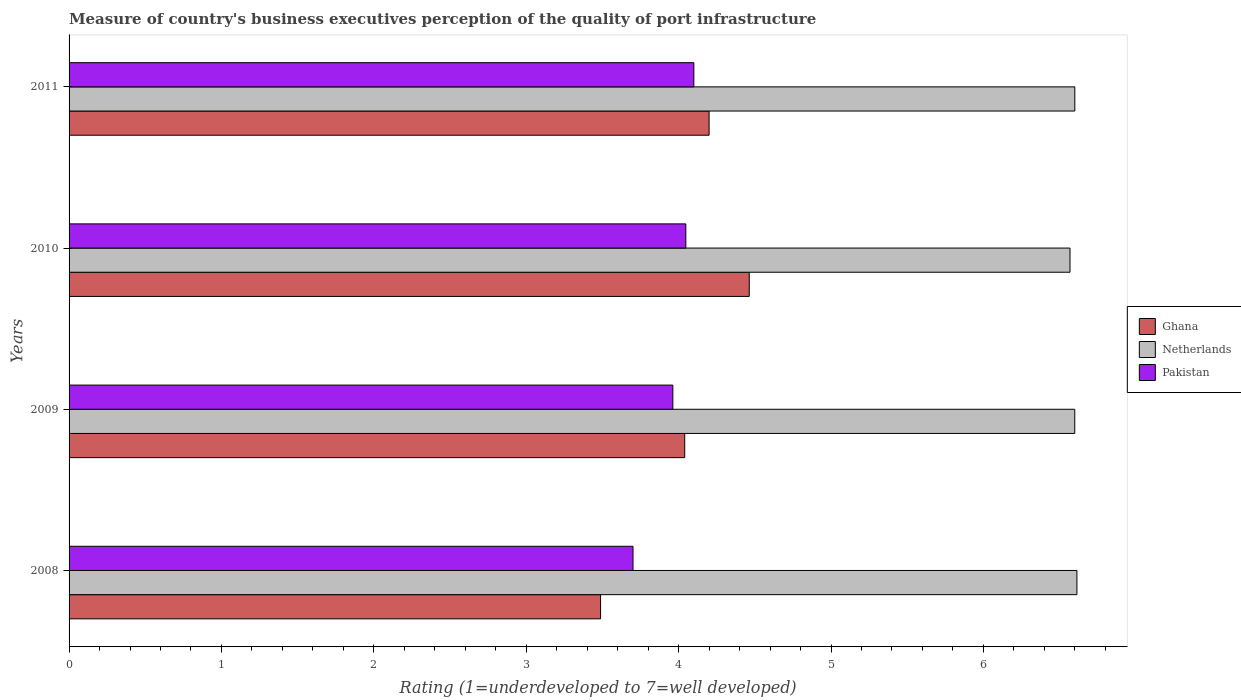How many different coloured bars are there?
Your answer should be compact. 3. How many groups of bars are there?
Offer a very short reply. 4. Are the number of bars per tick equal to the number of legend labels?
Make the answer very short. Yes. How many bars are there on the 2nd tick from the bottom?
Make the answer very short. 3. What is the ratings of the quality of port infrastructure in Ghana in 2009?
Offer a very short reply. 4.04. Across all years, what is the maximum ratings of the quality of port infrastructure in Pakistan?
Provide a short and direct response. 4.1. Across all years, what is the minimum ratings of the quality of port infrastructure in Pakistan?
Offer a terse response. 3.7. In which year was the ratings of the quality of port infrastructure in Ghana maximum?
Your answer should be compact. 2010. What is the total ratings of the quality of port infrastructure in Ghana in the graph?
Provide a succinct answer. 16.19. What is the difference between the ratings of the quality of port infrastructure in Netherlands in 2008 and that in 2011?
Your answer should be compact. 0.01. What is the difference between the ratings of the quality of port infrastructure in Ghana in 2009 and the ratings of the quality of port infrastructure in Netherlands in 2008?
Ensure brevity in your answer.  -2.57. What is the average ratings of the quality of port infrastructure in Ghana per year?
Your answer should be very brief. 4.05. In the year 2010, what is the difference between the ratings of the quality of port infrastructure in Netherlands and ratings of the quality of port infrastructure in Pakistan?
Keep it short and to the point. 2.52. In how many years, is the ratings of the quality of port infrastructure in Pakistan greater than 6.6 ?
Provide a short and direct response. 0. What is the ratio of the ratings of the quality of port infrastructure in Netherlands in 2010 to that in 2011?
Offer a terse response. 1. Is the ratings of the quality of port infrastructure in Netherlands in 2008 less than that in 2010?
Offer a terse response. No. What is the difference between the highest and the second highest ratings of the quality of port infrastructure in Netherlands?
Keep it short and to the point. 0.01. What is the difference between the highest and the lowest ratings of the quality of port infrastructure in Netherlands?
Your answer should be compact. 0.05. In how many years, is the ratings of the quality of port infrastructure in Netherlands greater than the average ratings of the quality of port infrastructure in Netherlands taken over all years?
Offer a terse response. 3. What does the 1st bar from the top in 2009 represents?
Keep it short and to the point. Pakistan. How many bars are there?
Provide a short and direct response. 12. How many years are there in the graph?
Give a very brief answer. 4. What is the difference between two consecutive major ticks on the X-axis?
Ensure brevity in your answer.  1. Are the values on the major ticks of X-axis written in scientific E-notation?
Your response must be concise. No. Does the graph contain grids?
Provide a short and direct response. No. Where does the legend appear in the graph?
Offer a terse response. Center right. How are the legend labels stacked?
Give a very brief answer. Vertical. What is the title of the graph?
Give a very brief answer. Measure of country's business executives perception of the quality of port infrastructure. What is the label or title of the X-axis?
Your response must be concise. Rating (1=underdeveloped to 7=well developed). What is the label or title of the Y-axis?
Your answer should be very brief. Years. What is the Rating (1=underdeveloped to 7=well developed) in Ghana in 2008?
Your answer should be compact. 3.49. What is the Rating (1=underdeveloped to 7=well developed) of Netherlands in 2008?
Your answer should be compact. 6.61. What is the Rating (1=underdeveloped to 7=well developed) in Pakistan in 2008?
Make the answer very short. 3.7. What is the Rating (1=underdeveloped to 7=well developed) of Ghana in 2009?
Ensure brevity in your answer.  4.04. What is the Rating (1=underdeveloped to 7=well developed) of Netherlands in 2009?
Ensure brevity in your answer.  6.6. What is the Rating (1=underdeveloped to 7=well developed) in Pakistan in 2009?
Provide a succinct answer. 3.96. What is the Rating (1=underdeveloped to 7=well developed) in Ghana in 2010?
Make the answer very short. 4.46. What is the Rating (1=underdeveloped to 7=well developed) in Netherlands in 2010?
Provide a succinct answer. 6.57. What is the Rating (1=underdeveloped to 7=well developed) of Pakistan in 2010?
Make the answer very short. 4.05. What is the Rating (1=underdeveloped to 7=well developed) of Netherlands in 2011?
Offer a very short reply. 6.6. Across all years, what is the maximum Rating (1=underdeveloped to 7=well developed) in Ghana?
Offer a terse response. 4.46. Across all years, what is the maximum Rating (1=underdeveloped to 7=well developed) of Netherlands?
Give a very brief answer. 6.61. Across all years, what is the maximum Rating (1=underdeveloped to 7=well developed) of Pakistan?
Offer a very short reply. 4.1. Across all years, what is the minimum Rating (1=underdeveloped to 7=well developed) in Ghana?
Your answer should be compact. 3.49. Across all years, what is the minimum Rating (1=underdeveloped to 7=well developed) of Netherlands?
Your response must be concise. 6.57. Across all years, what is the minimum Rating (1=underdeveloped to 7=well developed) of Pakistan?
Make the answer very short. 3.7. What is the total Rating (1=underdeveloped to 7=well developed) of Ghana in the graph?
Your answer should be very brief. 16.19. What is the total Rating (1=underdeveloped to 7=well developed) in Netherlands in the graph?
Give a very brief answer. 26.38. What is the total Rating (1=underdeveloped to 7=well developed) in Pakistan in the graph?
Provide a succinct answer. 15.81. What is the difference between the Rating (1=underdeveloped to 7=well developed) of Ghana in 2008 and that in 2009?
Keep it short and to the point. -0.55. What is the difference between the Rating (1=underdeveloped to 7=well developed) in Netherlands in 2008 and that in 2009?
Ensure brevity in your answer.  0.01. What is the difference between the Rating (1=underdeveloped to 7=well developed) of Pakistan in 2008 and that in 2009?
Offer a terse response. -0.26. What is the difference between the Rating (1=underdeveloped to 7=well developed) in Ghana in 2008 and that in 2010?
Offer a very short reply. -0.98. What is the difference between the Rating (1=underdeveloped to 7=well developed) of Netherlands in 2008 and that in 2010?
Make the answer very short. 0.05. What is the difference between the Rating (1=underdeveloped to 7=well developed) in Pakistan in 2008 and that in 2010?
Your response must be concise. -0.35. What is the difference between the Rating (1=underdeveloped to 7=well developed) of Ghana in 2008 and that in 2011?
Keep it short and to the point. -0.71. What is the difference between the Rating (1=underdeveloped to 7=well developed) of Netherlands in 2008 and that in 2011?
Offer a terse response. 0.01. What is the difference between the Rating (1=underdeveloped to 7=well developed) of Pakistan in 2008 and that in 2011?
Keep it short and to the point. -0.4. What is the difference between the Rating (1=underdeveloped to 7=well developed) in Ghana in 2009 and that in 2010?
Your answer should be very brief. -0.42. What is the difference between the Rating (1=underdeveloped to 7=well developed) of Netherlands in 2009 and that in 2010?
Offer a very short reply. 0.03. What is the difference between the Rating (1=underdeveloped to 7=well developed) of Pakistan in 2009 and that in 2010?
Your answer should be very brief. -0.09. What is the difference between the Rating (1=underdeveloped to 7=well developed) of Ghana in 2009 and that in 2011?
Your answer should be very brief. -0.16. What is the difference between the Rating (1=underdeveloped to 7=well developed) of Netherlands in 2009 and that in 2011?
Your answer should be compact. -0. What is the difference between the Rating (1=underdeveloped to 7=well developed) of Pakistan in 2009 and that in 2011?
Your answer should be compact. -0.14. What is the difference between the Rating (1=underdeveloped to 7=well developed) in Ghana in 2010 and that in 2011?
Your answer should be very brief. 0.26. What is the difference between the Rating (1=underdeveloped to 7=well developed) in Netherlands in 2010 and that in 2011?
Ensure brevity in your answer.  -0.03. What is the difference between the Rating (1=underdeveloped to 7=well developed) of Pakistan in 2010 and that in 2011?
Ensure brevity in your answer.  -0.05. What is the difference between the Rating (1=underdeveloped to 7=well developed) of Ghana in 2008 and the Rating (1=underdeveloped to 7=well developed) of Netherlands in 2009?
Give a very brief answer. -3.11. What is the difference between the Rating (1=underdeveloped to 7=well developed) of Ghana in 2008 and the Rating (1=underdeveloped to 7=well developed) of Pakistan in 2009?
Your answer should be very brief. -0.47. What is the difference between the Rating (1=underdeveloped to 7=well developed) of Netherlands in 2008 and the Rating (1=underdeveloped to 7=well developed) of Pakistan in 2009?
Keep it short and to the point. 2.65. What is the difference between the Rating (1=underdeveloped to 7=well developed) of Ghana in 2008 and the Rating (1=underdeveloped to 7=well developed) of Netherlands in 2010?
Keep it short and to the point. -3.08. What is the difference between the Rating (1=underdeveloped to 7=well developed) in Ghana in 2008 and the Rating (1=underdeveloped to 7=well developed) in Pakistan in 2010?
Make the answer very short. -0.56. What is the difference between the Rating (1=underdeveloped to 7=well developed) in Netherlands in 2008 and the Rating (1=underdeveloped to 7=well developed) in Pakistan in 2010?
Offer a terse response. 2.57. What is the difference between the Rating (1=underdeveloped to 7=well developed) of Ghana in 2008 and the Rating (1=underdeveloped to 7=well developed) of Netherlands in 2011?
Provide a short and direct response. -3.11. What is the difference between the Rating (1=underdeveloped to 7=well developed) in Ghana in 2008 and the Rating (1=underdeveloped to 7=well developed) in Pakistan in 2011?
Make the answer very short. -0.61. What is the difference between the Rating (1=underdeveloped to 7=well developed) of Netherlands in 2008 and the Rating (1=underdeveloped to 7=well developed) of Pakistan in 2011?
Ensure brevity in your answer.  2.51. What is the difference between the Rating (1=underdeveloped to 7=well developed) of Ghana in 2009 and the Rating (1=underdeveloped to 7=well developed) of Netherlands in 2010?
Your answer should be very brief. -2.53. What is the difference between the Rating (1=underdeveloped to 7=well developed) of Ghana in 2009 and the Rating (1=underdeveloped to 7=well developed) of Pakistan in 2010?
Keep it short and to the point. -0.01. What is the difference between the Rating (1=underdeveloped to 7=well developed) in Netherlands in 2009 and the Rating (1=underdeveloped to 7=well developed) in Pakistan in 2010?
Provide a short and direct response. 2.55. What is the difference between the Rating (1=underdeveloped to 7=well developed) in Ghana in 2009 and the Rating (1=underdeveloped to 7=well developed) in Netherlands in 2011?
Provide a succinct answer. -2.56. What is the difference between the Rating (1=underdeveloped to 7=well developed) in Ghana in 2009 and the Rating (1=underdeveloped to 7=well developed) in Pakistan in 2011?
Your response must be concise. -0.06. What is the difference between the Rating (1=underdeveloped to 7=well developed) in Netherlands in 2009 and the Rating (1=underdeveloped to 7=well developed) in Pakistan in 2011?
Offer a very short reply. 2.5. What is the difference between the Rating (1=underdeveloped to 7=well developed) in Ghana in 2010 and the Rating (1=underdeveloped to 7=well developed) in Netherlands in 2011?
Keep it short and to the point. -2.14. What is the difference between the Rating (1=underdeveloped to 7=well developed) of Ghana in 2010 and the Rating (1=underdeveloped to 7=well developed) of Pakistan in 2011?
Your answer should be very brief. 0.36. What is the difference between the Rating (1=underdeveloped to 7=well developed) in Netherlands in 2010 and the Rating (1=underdeveloped to 7=well developed) in Pakistan in 2011?
Make the answer very short. 2.47. What is the average Rating (1=underdeveloped to 7=well developed) in Ghana per year?
Keep it short and to the point. 4.05. What is the average Rating (1=underdeveloped to 7=well developed) in Netherlands per year?
Make the answer very short. 6.6. What is the average Rating (1=underdeveloped to 7=well developed) of Pakistan per year?
Your answer should be very brief. 3.95. In the year 2008, what is the difference between the Rating (1=underdeveloped to 7=well developed) in Ghana and Rating (1=underdeveloped to 7=well developed) in Netherlands?
Provide a short and direct response. -3.13. In the year 2008, what is the difference between the Rating (1=underdeveloped to 7=well developed) in Ghana and Rating (1=underdeveloped to 7=well developed) in Pakistan?
Your answer should be compact. -0.21. In the year 2008, what is the difference between the Rating (1=underdeveloped to 7=well developed) in Netherlands and Rating (1=underdeveloped to 7=well developed) in Pakistan?
Your answer should be very brief. 2.91. In the year 2009, what is the difference between the Rating (1=underdeveloped to 7=well developed) in Ghana and Rating (1=underdeveloped to 7=well developed) in Netherlands?
Provide a succinct answer. -2.56. In the year 2009, what is the difference between the Rating (1=underdeveloped to 7=well developed) of Ghana and Rating (1=underdeveloped to 7=well developed) of Pakistan?
Make the answer very short. 0.08. In the year 2009, what is the difference between the Rating (1=underdeveloped to 7=well developed) in Netherlands and Rating (1=underdeveloped to 7=well developed) in Pakistan?
Offer a terse response. 2.64. In the year 2010, what is the difference between the Rating (1=underdeveloped to 7=well developed) of Ghana and Rating (1=underdeveloped to 7=well developed) of Netherlands?
Offer a very short reply. -2.1. In the year 2010, what is the difference between the Rating (1=underdeveloped to 7=well developed) of Ghana and Rating (1=underdeveloped to 7=well developed) of Pakistan?
Ensure brevity in your answer.  0.42. In the year 2010, what is the difference between the Rating (1=underdeveloped to 7=well developed) of Netherlands and Rating (1=underdeveloped to 7=well developed) of Pakistan?
Make the answer very short. 2.52. In the year 2011, what is the difference between the Rating (1=underdeveloped to 7=well developed) in Ghana and Rating (1=underdeveloped to 7=well developed) in Netherlands?
Ensure brevity in your answer.  -2.4. In the year 2011, what is the difference between the Rating (1=underdeveloped to 7=well developed) in Ghana and Rating (1=underdeveloped to 7=well developed) in Pakistan?
Provide a short and direct response. 0.1. In the year 2011, what is the difference between the Rating (1=underdeveloped to 7=well developed) in Netherlands and Rating (1=underdeveloped to 7=well developed) in Pakistan?
Ensure brevity in your answer.  2.5. What is the ratio of the Rating (1=underdeveloped to 7=well developed) of Ghana in 2008 to that in 2009?
Keep it short and to the point. 0.86. What is the ratio of the Rating (1=underdeveloped to 7=well developed) in Netherlands in 2008 to that in 2009?
Provide a succinct answer. 1. What is the ratio of the Rating (1=underdeveloped to 7=well developed) in Pakistan in 2008 to that in 2009?
Your answer should be compact. 0.93. What is the ratio of the Rating (1=underdeveloped to 7=well developed) of Ghana in 2008 to that in 2010?
Offer a very short reply. 0.78. What is the ratio of the Rating (1=underdeveloped to 7=well developed) of Netherlands in 2008 to that in 2010?
Your answer should be compact. 1.01. What is the ratio of the Rating (1=underdeveloped to 7=well developed) in Pakistan in 2008 to that in 2010?
Offer a terse response. 0.91. What is the ratio of the Rating (1=underdeveloped to 7=well developed) in Ghana in 2008 to that in 2011?
Provide a succinct answer. 0.83. What is the ratio of the Rating (1=underdeveloped to 7=well developed) in Pakistan in 2008 to that in 2011?
Offer a terse response. 0.9. What is the ratio of the Rating (1=underdeveloped to 7=well developed) of Ghana in 2009 to that in 2010?
Offer a very short reply. 0.91. What is the ratio of the Rating (1=underdeveloped to 7=well developed) of Netherlands in 2009 to that in 2010?
Provide a succinct answer. 1. What is the ratio of the Rating (1=underdeveloped to 7=well developed) of Pakistan in 2009 to that in 2010?
Give a very brief answer. 0.98. What is the ratio of the Rating (1=underdeveloped to 7=well developed) of Ghana in 2009 to that in 2011?
Your response must be concise. 0.96. What is the ratio of the Rating (1=underdeveloped to 7=well developed) in Netherlands in 2009 to that in 2011?
Provide a short and direct response. 1. What is the ratio of the Rating (1=underdeveloped to 7=well developed) of Pakistan in 2009 to that in 2011?
Your answer should be compact. 0.97. What is the ratio of the Rating (1=underdeveloped to 7=well developed) in Ghana in 2010 to that in 2011?
Offer a very short reply. 1.06. What is the ratio of the Rating (1=underdeveloped to 7=well developed) in Netherlands in 2010 to that in 2011?
Offer a very short reply. 1. What is the ratio of the Rating (1=underdeveloped to 7=well developed) of Pakistan in 2010 to that in 2011?
Your answer should be very brief. 0.99. What is the difference between the highest and the second highest Rating (1=underdeveloped to 7=well developed) in Ghana?
Give a very brief answer. 0.26. What is the difference between the highest and the second highest Rating (1=underdeveloped to 7=well developed) of Netherlands?
Your response must be concise. 0.01. What is the difference between the highest and the second highest Rating (1=underdeveloped to 7=well developed) in Pakistan?
Make the answer very short. 0.05. What is the difference between the highest and the lowest Rating (1=underdeveloped to 7=well developed) of Ghana?
Make the answer very short. 0.98. What is the difference between the highest and the lowest Rating (1=underdeveloped to 7=well developed) in Netherlands?
Give a very brief answer. 0.05. What is the difference between the highest and the lowest Rating (1=underdeveloped to 7=well developed) of Pakistan?
Offer a terse response. 0.4. 